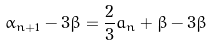<formula> <loc_0><loc_0><loc_500><loc_500>\alpha _ { n + 1 } - 3 \beta = \frac { 2 } { 3 } a _ { n } + \beta - 3 \beta</formula> 